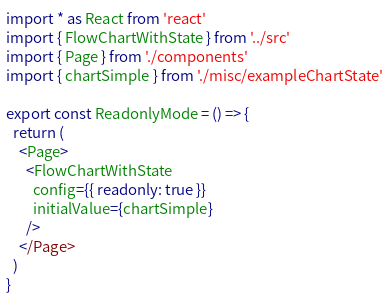Convert code to text. <code><loc_0><loc_0><loc_500><loc_500><_TypeScript_>import * as React from 'react'
import { FlowChartWithState } from '../src'
import { Page } from './components'
import { chartSimple } from './misc/exampleChartState'

export const ReadonlyMode = () => {
  return (
    <Page>
      <FlowChartWithState
        config={{ readonly: true }}
        initialValue={chartSimple}
      />
    </Page>
  )
}
</code> 